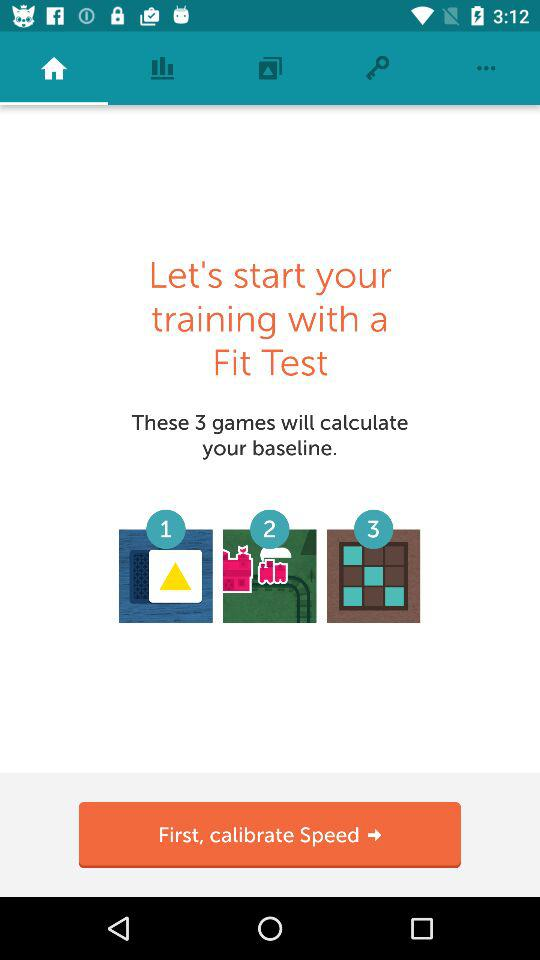How many games will calculate the baseline? The number of games that will calculate your baseline is 3. 